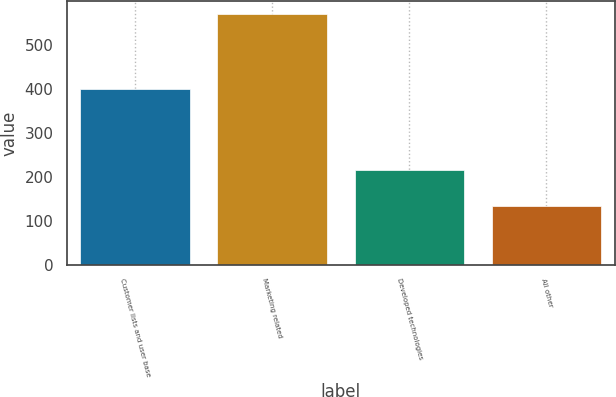<chart> <loc_0><loc_0><loc_500><loc_500><bar_chart><fcel>Customer lists and user base<fcel>Marketing related<fcel>Developed technologies<fcel>All other<nl><fcel>399<fcel>570<fcel>215<fcel>134<nl></chart> 